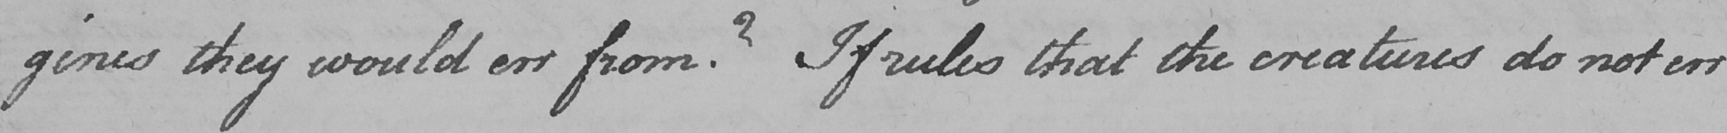What is written in this line of handwriting? gines they would err from ?  If rules that the creatures do not err 